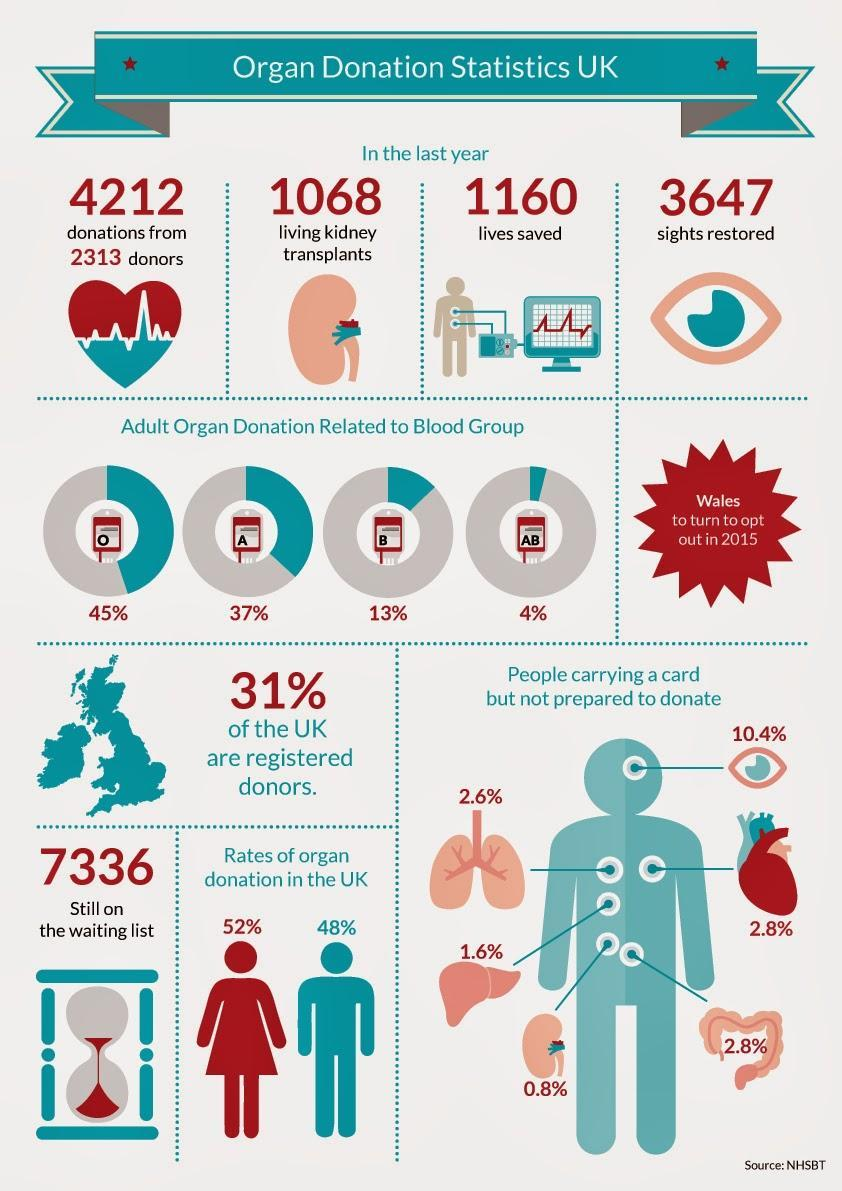How many kidney transplants have been made ?
Answer the question with a short phrase. 1068 What percent of of UK citizens are not  registered donors ? 69% Which is the organ shown in the second image ? Kidney Which blood group has the least number of organ donors ? AB What percent of card holders are willing to donate their eyes ? 89.6% How many lives have been saved through organ donation last year ? 1160 How many are still awaiting donors for organs ? 7336 Are Organ donors in UK mostly men or women ? Women People belonging to which blood group have made the highest percentage of organ donation - A, AB, O or B ? O What percent of card holders are not prepared to donate a kidney ? 0.8% 